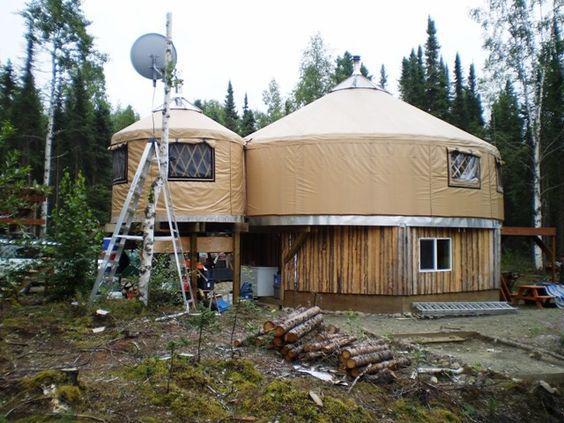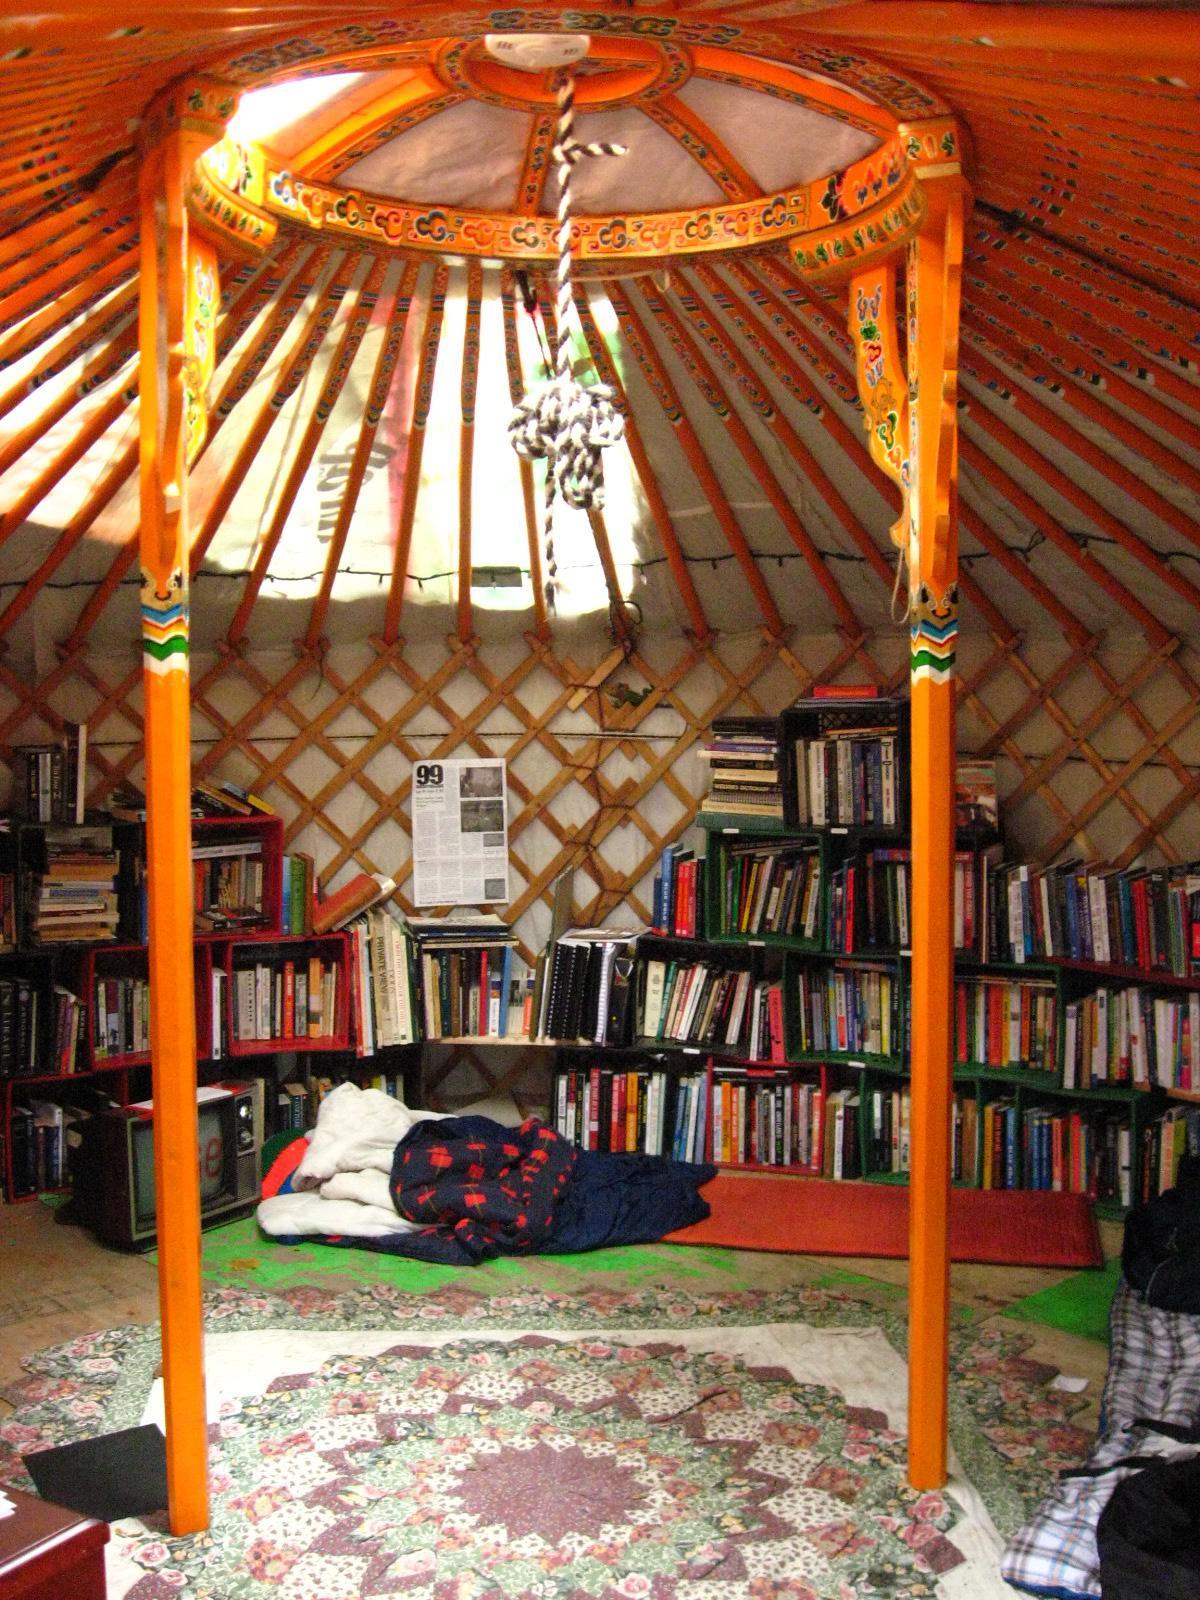The first image is the image on the left, the second image is the image on the right. Given the left and right images, does the statement "One image shows the interior of a yurt with at least two support beams and latticed walls, with a light fixture hanging from the center of the ceiling." hold true? Answer yes or no. Yes. The first image is the image on the left, the second image is the image on the right. Given the left and right images, does the statement "The right image contains at least one human being." hold true? Answer yes or no. No. 